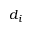Convert formula to latex. <formula><loc_0><loc_0><loc_500><loc_500>d _ { i }</formula> 